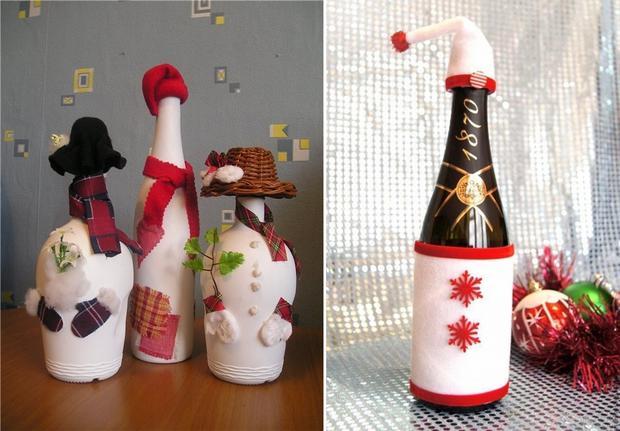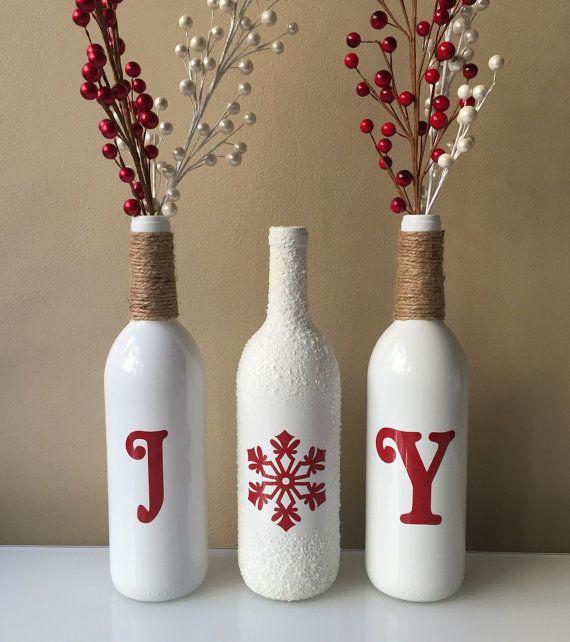The first image is the image on the left, the second image is the image on the right. Examine the images to the left and right. Is the description "All of the bottles look like snowmen." accurate? Answer yes or no. No. 